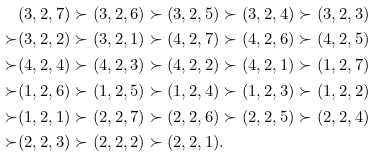Convert formula to latex. <formula><loc_0><loc_0><loc_500><loc_500>& ( 3 , 2 , 7 ) \succ ( 3 , 2 , 6 ) \succ ( 3 , 2 , 5 ) \succ ( 3 , 2 , 4 ) \succ ( 3 , 2 , 3 ) \\ \succ & ( 3 , 2 , 2 ) \succ ( 3 , 2 , 1 ) \succ ( 4 , 2 , 7 ) \succ ( 4 , 2 , 6 ) \succ ( 4 , 2 , 5 ) \\ \succ & ( 4 , 2 , 4 ) \succ ( 4 , 2 , 3 ) \succ ( 4 , 2 , 2 ) \succ ( 4 , 2 , 1 ) \succ ( 1 , 2 , 7 ) \\ \succ & ( 1 , 2 , 6 ) \succ ( 1 , 2 , 5 ) \succ ( 1 , 2 , 4 ) \succ ( 1 , 2 , 3 ) \succ ( 1 , 2 , 2 ) \\ \succ & ( 1 , 2 , 1 ) \succ ( 2 , 2 , 7 ) \succ ( 2 , 2 , 6 ) \succ ( 2 , 2 , 5 ) \succ ( 2 , 2 , 4 ) \\ \succ & ( 2 , 2 , 3 ) \succ ( 2 , 2 , 2 ) \succ ( 2 , 2 , 1 ) .</formula> 